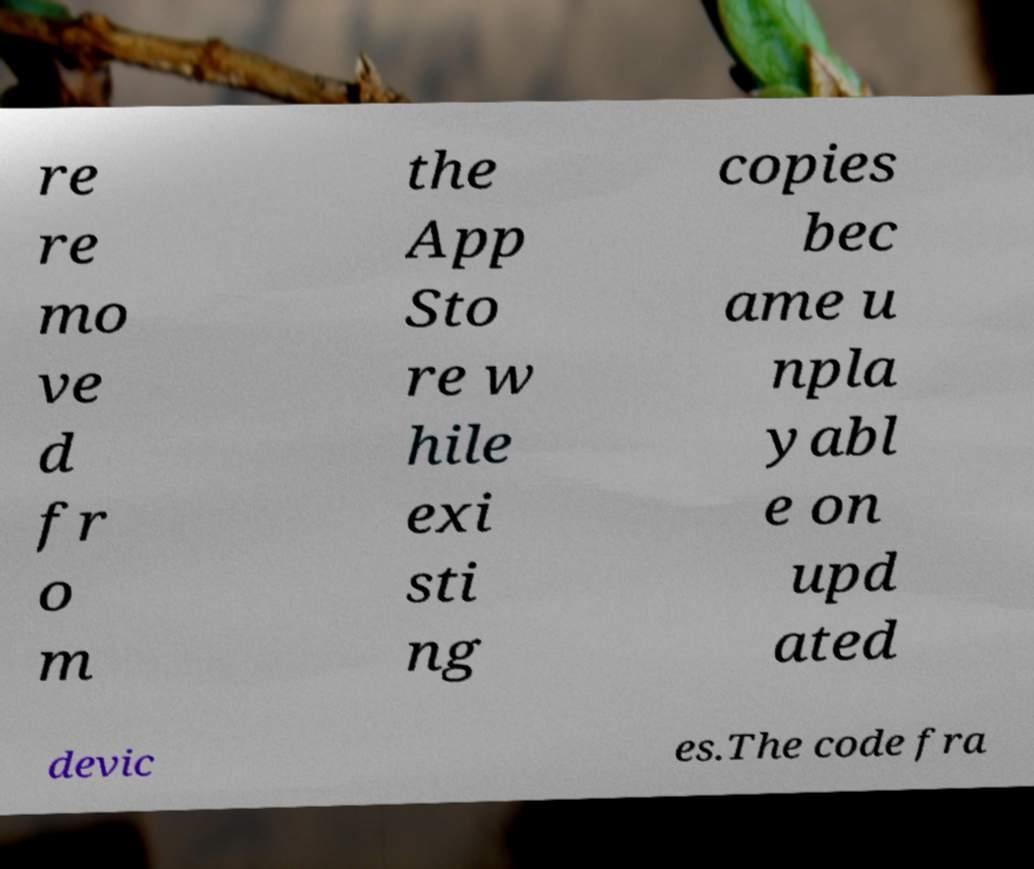I need the written content from this picture converted into text. Can you do that? re re mo ve d fr o m the App Sto re w hile exi sti ng copies bec ame u npla yabl e on upd ated devic es.The code fra 